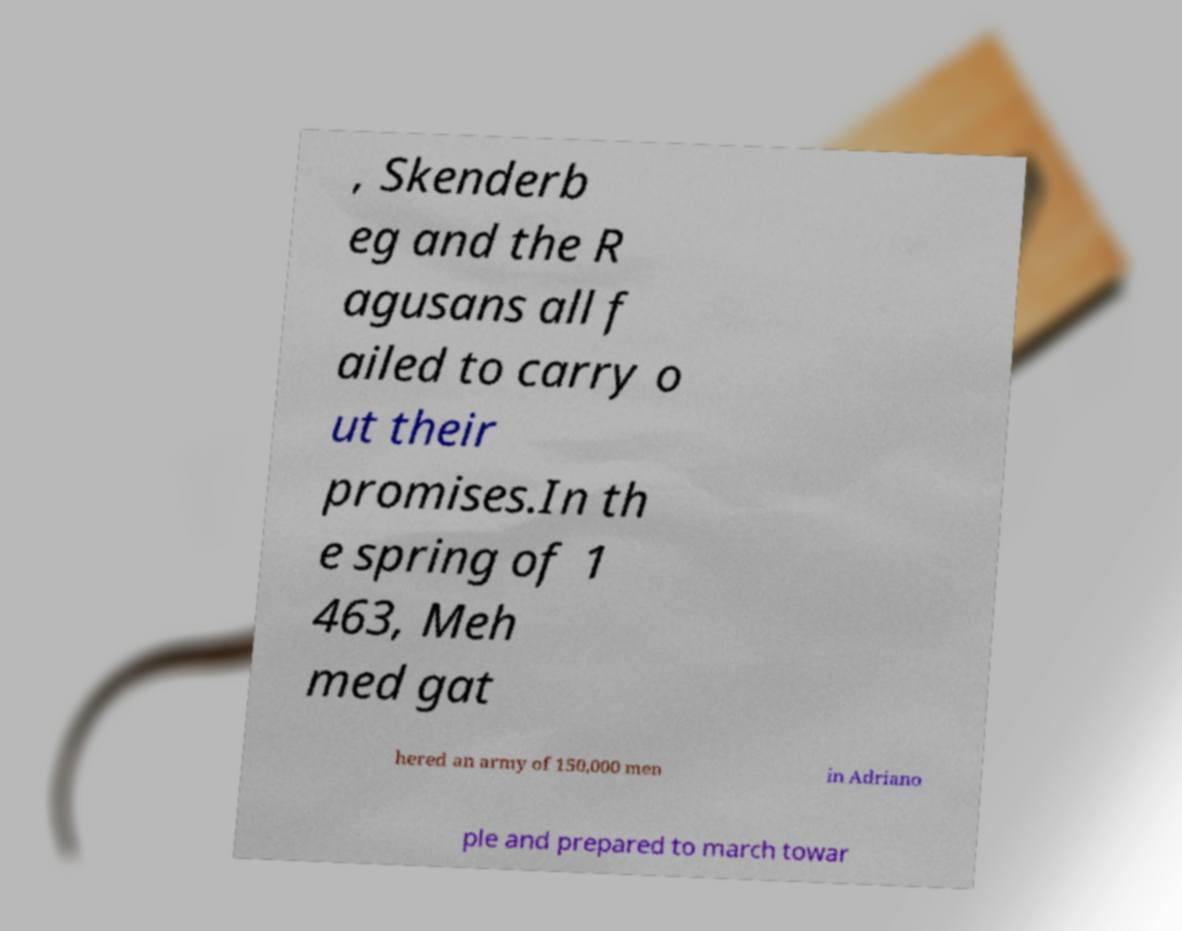Please read and relay the text visible in this image. What does it say? , Skenderb eg and the R agusans all f ailed to carry o ut their promises.In th e spring of 1 463, Meh med gat hered an army of 150,000 men in Adriano ple and prepared to march towar 